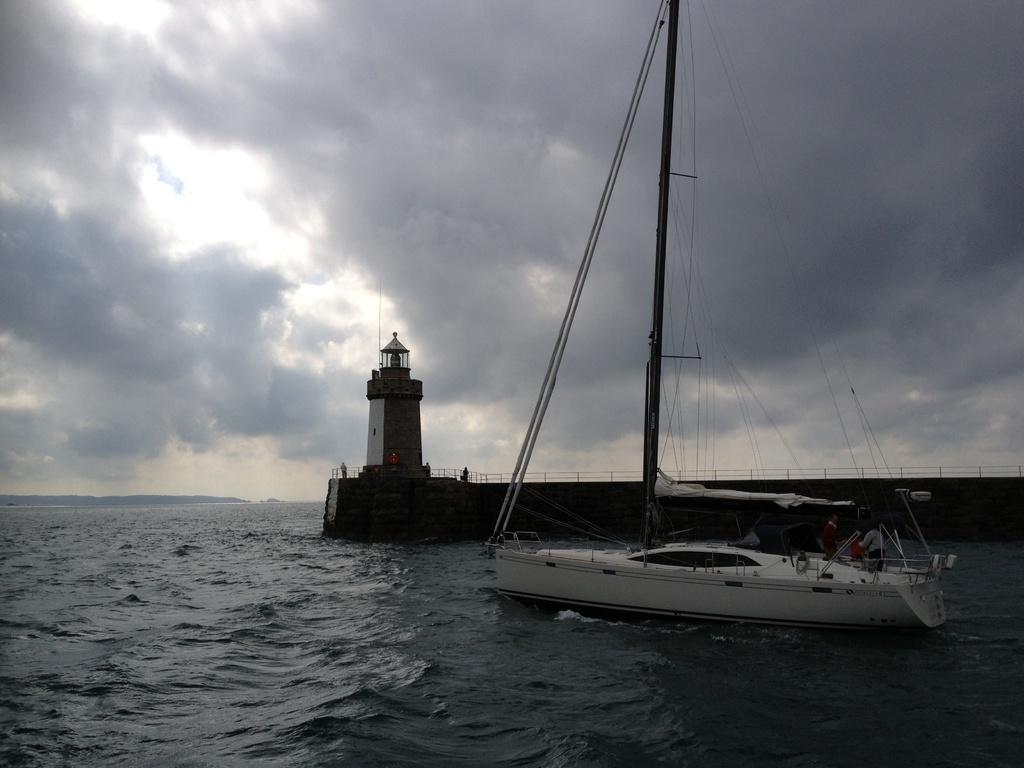In one or two sentences, can you explain what this image depicts? In this picture there is a ship on the right side of the image, on the water and there is a tower in the center of the image, there is water at the bottom side of the image. 